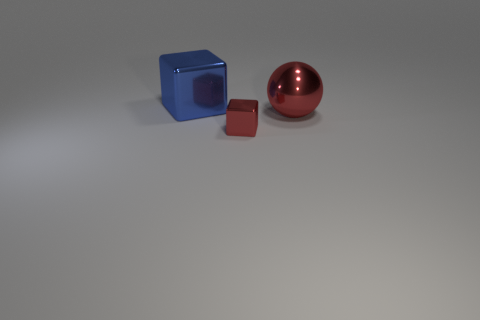Add 3 big green matte cylinders. How many objects exist? 6 Subtract all cubes. How many objects are left? 1 Add 2 red blocks. How many red blocks exist? 3 Subtract 0 blue cylinders. How many objects are left? 3 Subtract all tiny balls. Subtract all large blue objects. How many objects are left? 2 Add 1 metallic things. How many metallic things are left? 4 